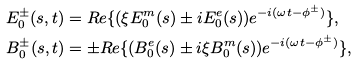Convert formula to latex. <formula><loc_0><loc_0><loc_500><loc_500>& E _ { 0 } ^ { \pm } ( s , t ) = R e \{ ( \xi E _ { 0 } ^ { m } ( s ) \pm i E _ { 0 } ^ { e } ( s ) ) e ^ { - i ( \omega t - \phi ^ { \pm } ) } \} , \\ & B _ { 0 } ^ { \pm } ( s , t ) = \pm R e \{ ( B _ { 0 } ^ { e } ( s ) \pm i \xi B _ { 0 } ^ { m } ( s ) ) e ^ { - i ( \omega t - \phi ^ { \pm } ) } \} ,</formula> 